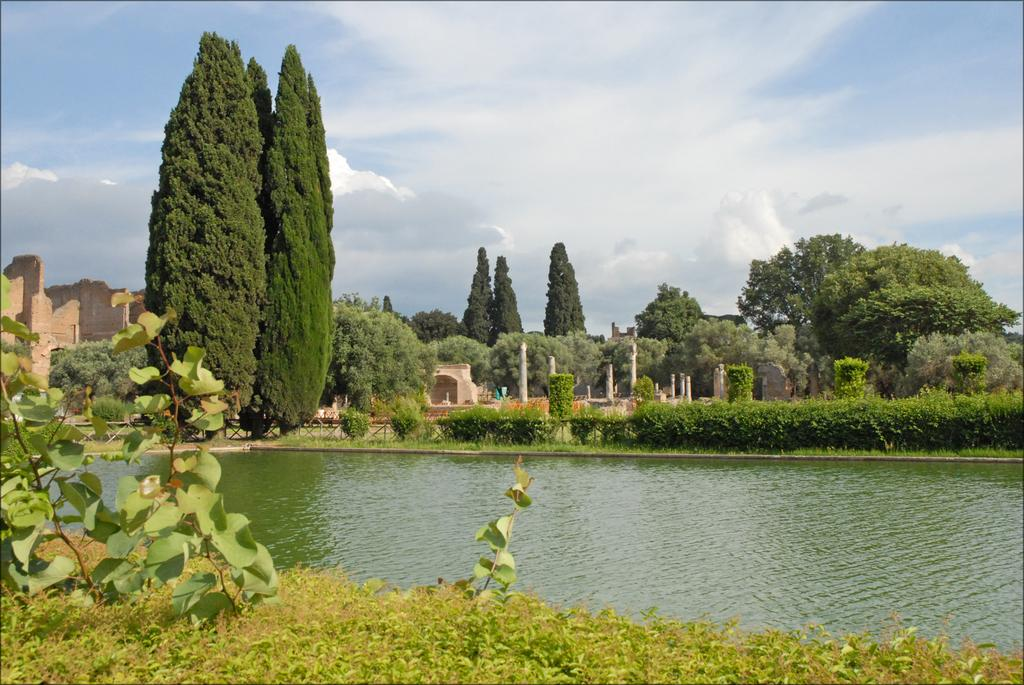What is the main feature of the image? The main feature of the image is a water surface. What can be seen around the water surface? The water surface is surrounded by a beautiful park. What kind of vegetation is present in the park? The park contains many trees and plants. What is visible in the background of the image? There is a fort in the background of the image. What type of parent-child relationship is depicted in the image? There is no parent-child relationship depicted in the image; it features a water surface, a park, trees, plants, and a fort in the background. 